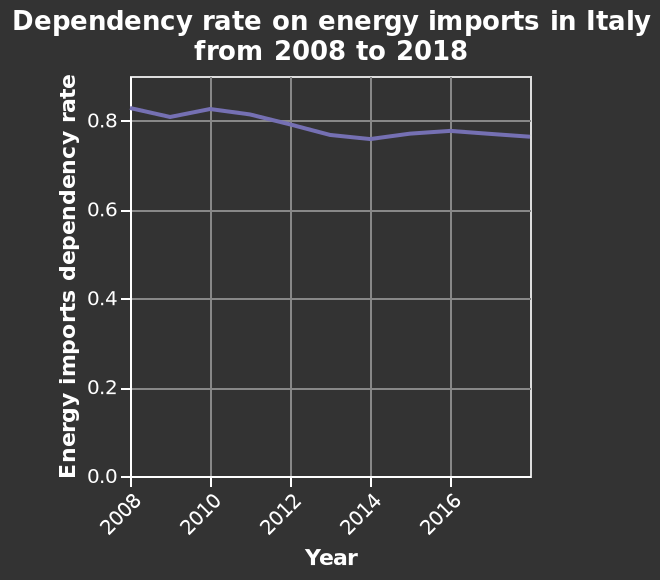<image>
What can be inferred from the graph about the energy imports dependancy rate between 2012 and 2014? The graph indicates that there was a significant deviation from the gradual decrease in the energy imports dependancy rate between 2012 and 2014, suggesting the influence of external factors. please describe the details of the chart Here a line graph is titled Dependency rate on energy imports in Italy from 2008 to 2018. The x-axis measures Year along linear scale from 2008 to 2016 while the y-axis plots Energy imports dependency rate using linear scale from 0.0 to 0.8. How did the energy imports dependency rate change between 2008 and 2010?  Between 2008 and 2010, there was a noticeable dip and sudden rise in the energy imports dependency rate. Was there any significant change in the energy imports dependency rate between 2012 and 2014? Yes, between 2012 and 2014 there was a more sharp decline and rise in the energy imports dependency rate. 